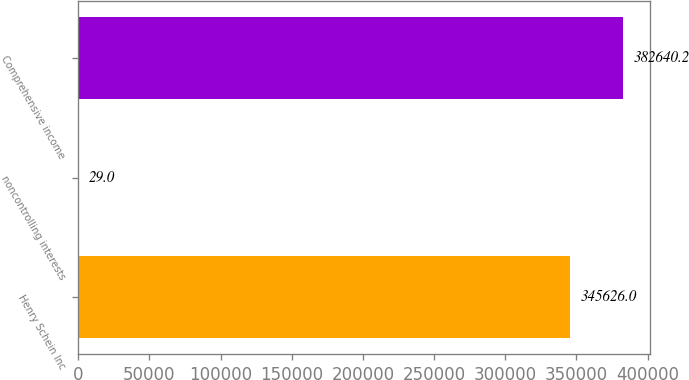Convert chart. <chart><loc_0><loc_0><loc_500><loc_500><bar_chart><fcel>Henry Schein Inc<fcel>noncontrolling interests<fcel>Comprehensive income<nl><fcel>345626<fcel>29<fcel>382640<nl></chart> 